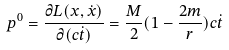<formula> <loc_0><loc_0><loc_500><loc_500>p ^ { 0 } = \frac { \partial L ( x , \dot { x } ) } { \partial ( c \dot { t } ) } = \frac { M } { 2 } ( 1 - \frac { 2 m } { r } ) c \dot { t }</formula> 